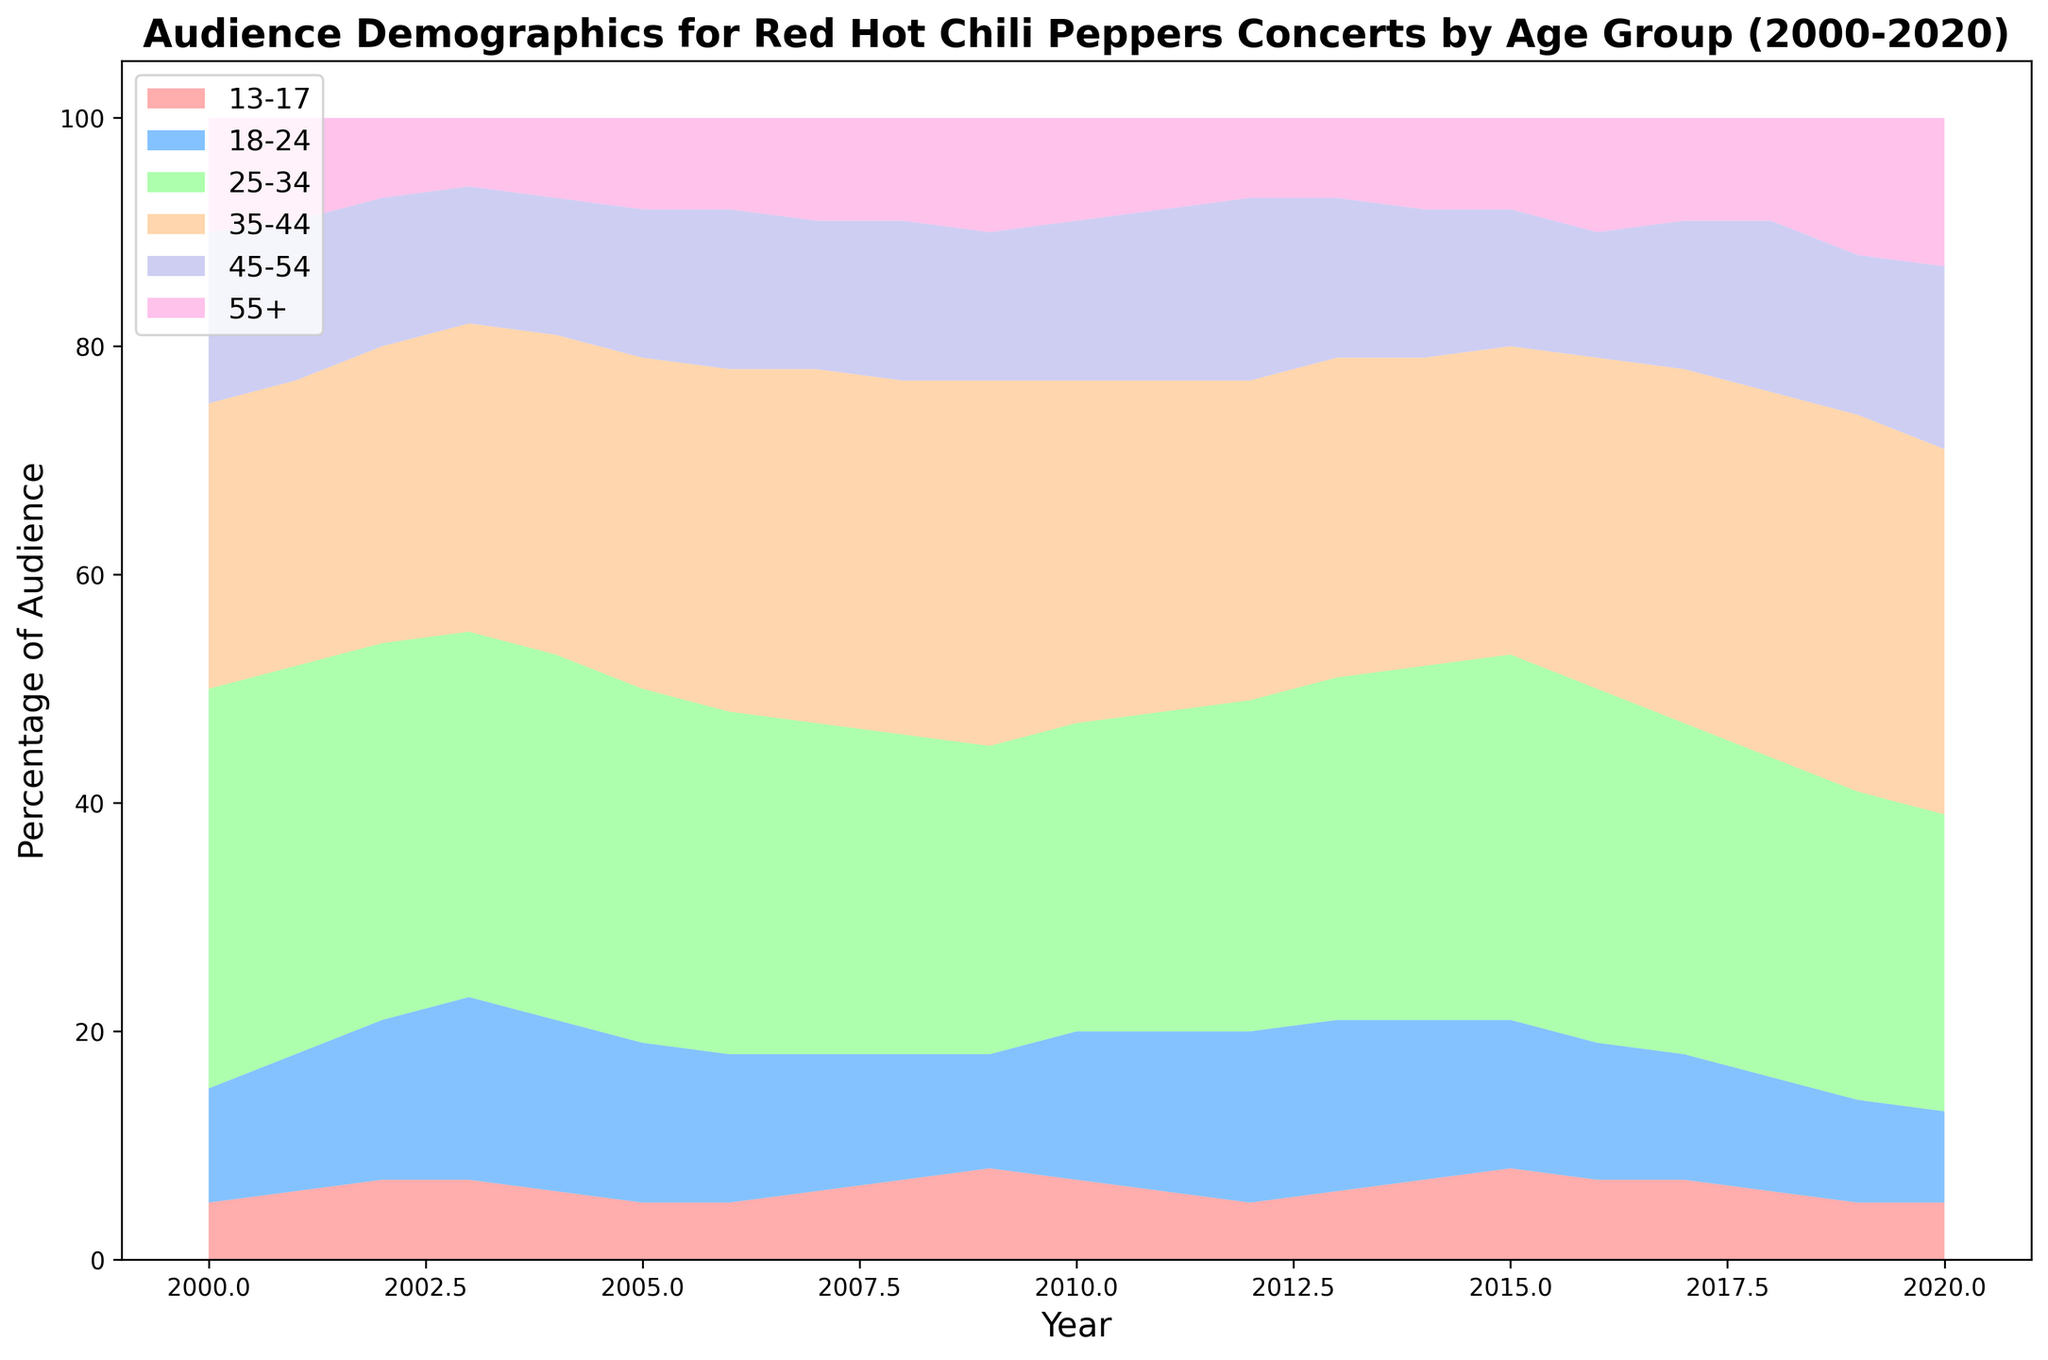What age group consistently had the highest audience percentage from 2000 to 2020? By looking at the layers in the area chart, we can see that the section representing the 25-34 age group is consistently the tallest and occupies the largest area across all years.
Answer: 25-34 Between which years did the 35-44 age group's audience percentage surpass the 25-34 age group's percentage? Examine the different sections in the chart for the periods when the area representing the 35-44 group is taller than the area for the 25-34 group. This never happens as the 25-34 age group consistently has the largest area.
Answer: Never How did the audience percentage of the 18-24 age group change from 2005 to 2010? Look at the chart and observe the height of the 18-24 section in the vertical axis from 2005 to 2010. The percentage decreased from around 14% in 2005 to about 13% in 2010.
Answer: Decreased What year did the 55+ age group start seeing increases in their audience percentage? Identify the section for the 55+ age group and track its height over the years. Notice that there is a gradual increasing trend that becomes more noticeable starting in 2016.
Answer: 2016 Which two age groups combined account for more than half of the audience percentage in 2020? Add the heights of different sections in the 2020 vertical axis, the sections for 25-34 and 35-44 combined are more than 50% of the total.
Answer: 25-34 and 35-44 What is the average percentage of the age group 13-17 across all years? Sum the percentages of the 13-17 group for all years and divide by the number of years (21 years). Total is 124, so the average is 124/21 ≈ 5.9.
Answer: 5.9 In which year did the 45-54 age group reach its peak audience percentage? Track the height of the 45-54 age group section over time. The peak occurs in 2020 with 16%.
Answer: 2020 Compare the trend of the 25-34 age group with the 55+ age group from 2000 to 2020. Observe the change in height for both sections: the 25-34 age group trend shows a decline, whereas the 55+ age group shows a gradual increase over the years.
Answer: Decline vs Increase How does the audience percentage of the 18-24 age group in 2000 compare to that in 2010? Compare the heights of the 18-24 section in the charts for 2000 and 2010. The percentage was around 10% in 2000 and increased to about 13% in 2010.
Answer: Increased What is the total change in audience percentage for the 35-44 age group from 2000 to 2020? Subtract the percentage in 2000 (25%) from the percentage in 2020 (32%). The total change is 32% - 25% = 7%.
Answer: 7% 